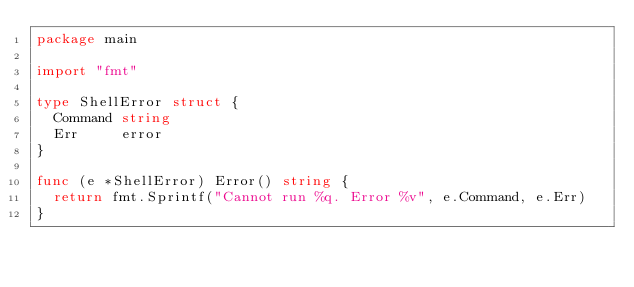Convert code to text. <code><loc_0><loc_0><loc_500><loc_500><_Go_>package main

import "fmt"

type ShellError struct {
	Command string
	Err     error
}

func (e *ShellError) Error() string {
	return fmt.Sprintf("Cannot run %q. Error %v", e.Command, e.Err)
}
</code> 